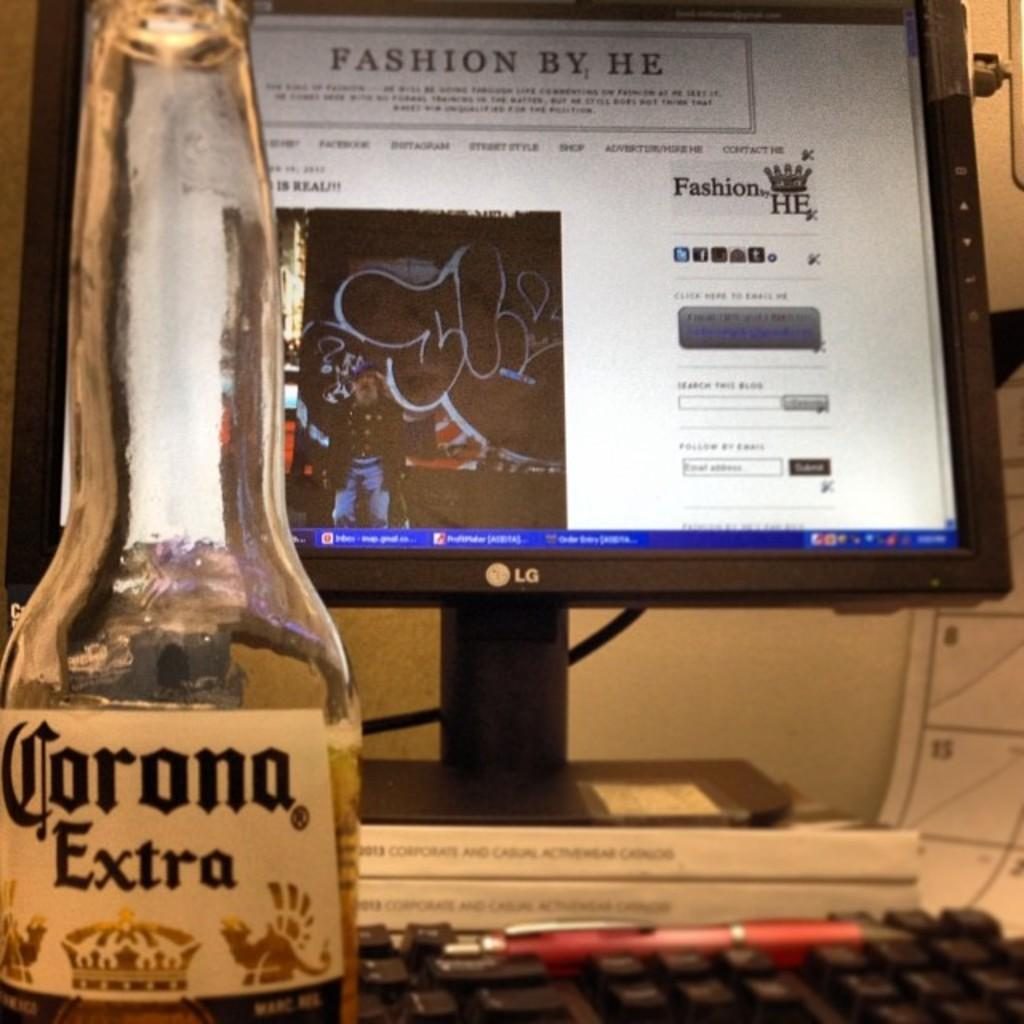<image>
Create a compact narrative representing the image presented. Lg computer is turned on a website called fashion by he 